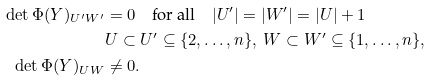Convert formula to latex. <formula><loc_0><loc_0><loc_500><loc_500>\det \Phi ( Y ) _ { U ^ { \prime } W ^ { \prime } } & = 0 \quad \text {for all} \quad | U ^ { \prime } | = | W ^ { \prime } | = | U | + 1 \\ & U \subset U ^ { \prime } \subseteq \{ 2 , \dots , n \} , \ W \subset W ^ { \prime } \subseteq \{ 1 , \dots , n \} , \\ \det \Phi ( Y ) _ { U W } & \neq 0 .</formula> 